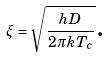<formula> <loc_0><loc_0><loc_500><loc_500>\xi = \sqrt { \frac { h D } { 2 \pi k T _ { c } } } \text {.}</formula> 